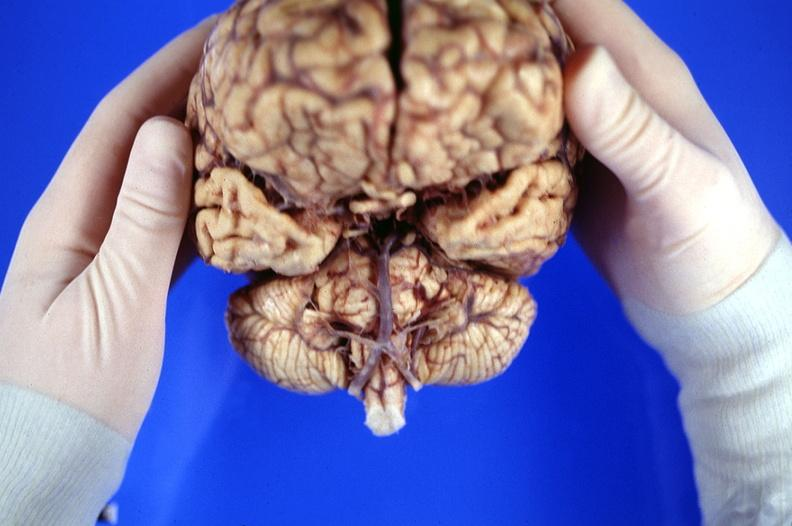s sella present?
Answer the question using a single word or phrase. No 